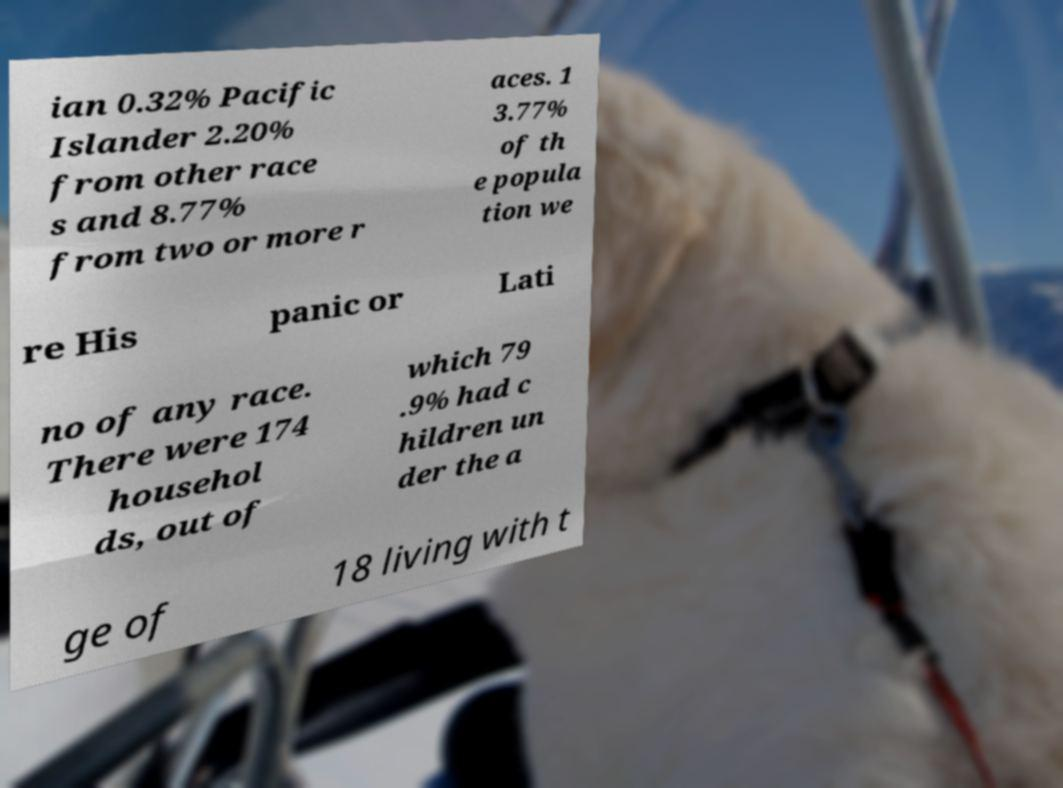Please identify and transcribe the text found in this image. ian 0.32% Pacific Islander 2.20% from other race s and 8.77% from two or more r aces. 1 3.77% of th e popula tion we re His panic or Lati no of any race. There were 174 househol ds, out of which 79 .9% had c hildren un der the a ge of 18 living with t 